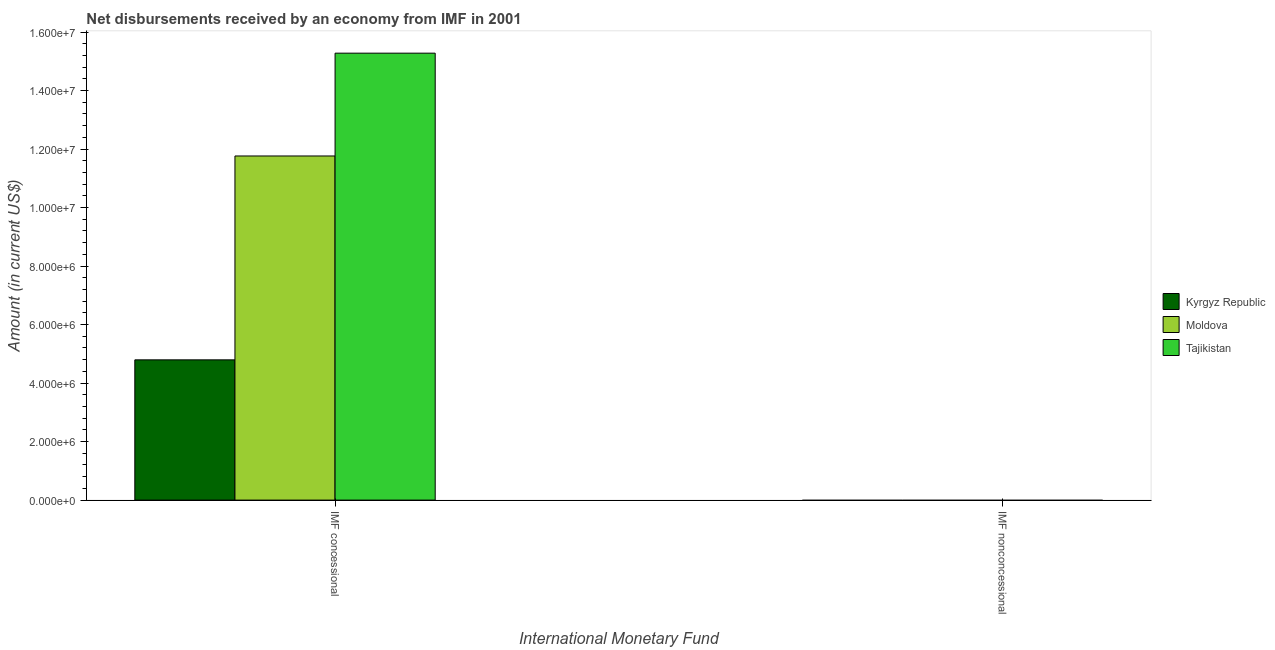Are the number of bars per tick equal to the number of legend labels?
Ensure brevity in your answer.  No. Are the number of bars on each tick of the X-axis equal?
Keep it short and to the point. No. How many bars are there on the 1st tick from the right?
Make the answer very short. 0. What is the label of the 2nd group of bars from the left?
Provide a succinct answer. IMF nonconcessional. Across all countries, what is the maximum net concessional disbursements from imf?
Your answer should be compact. 1.53e+07. Across all countries, what is the minimum net non concessional disbursements from imf?
Your answer should be very brief. 0. In which country was the net concessional disbursements from imf maximum?
Give a very brief answer. Tajikistan. What is the total net concessional disbursements from imf in the graph?
Your response must be concise. 3.18e+07. What is the difference between the net concessional disbursements from imf in Kyrgyz Republic and that in Moldova?
Ensure brevity in your answer.  -6.97e+06. What is the difference between the net non concessional disbursements from imf in Kyrgyz Republic and the net concessional disbursements from imf in Tajikistan?
Ensure brevity in your answer.  -1.53e+07. What is the average net concessional disbursements from imf per country?
Your answer should be very brief. 1.06e+07. What is the ratio of the net concessional disbursements from imf in Kyrgyz Republic to that in Moldova?
Ensure brevity in your answer.  0.41. Is the net concessional disbursements from imf in Moldova less than that in Kyrgyz Republic?
Your answer should be compact. No. In how many countries, is the net concessional disbursements from imf greater than the average net concessional disbursements from imf taken over all countries?
Offer a very short reply. 2. How many countries are there in the graph?
Your answer should be very brief. 3. What is the difference between two consecutive major ticks on the Y-axis?
Give a very brief answer. 2.00e+06. How are the legend labels stacked?
Your response must be concise. Vertical. What is the title of the graph?
Offer a terse response. Net disbursements received by an economy from IMF in 2001. Does "St. Lucia" appear as one of the legend labels in the graph?
Your answer should be very brief. No. What is the label or title of the X-axis?
Offer a terse response. International Monetary Fund. What is the label or title of the Y-axis?
Give a very brief answer. Amount (in current US$). What is the Amount (in current US$) in Kyrgyz Republic in IMF concessional?
Offer a terse response. 4.79e+06. What is the Amount (in current US$) of Moldova in IMF concessional?
Give a very brief answer. 1.18e+07. What is the Amount (in current US$) of Tajikistan in IMF concessional?
Keep it short and to the point. 1.53e+07. What is the Amount (in current US$) in Kyrgyz Republic in IMF nonconcessional?
Make the answer very short. 0. What is the Amount (in current US$) of Tajikistan in IMF nonconcessional?
Offer a very short reply. 0. Across all International Monetary Fund, what is the maximum Amount (in current US$) in Kyrgyz Republic?
Ensure brevity in your answer.  4.79e+06. Across all International Monetary Fund, what is the maximum Amount (in current US$) in Moldova?
Provide a succinct answer. 1.18e+07. Across all International Monetary Fund, what is the maximum Amount (in current US$) of Tajikistan?
Keep it short and to the point. 1.53e+07. What is the total Amount (in current US$) in Kyrgyz Republic in the graph?
Make the answer very short. 4.79e+06. What is the total Amount (in current US$) in Moldova in the graph?
Your response must be concise. 1.18e+07. What is the total Amount (in current US$) of Tajikistan in the graph?
Give a very brief answer. 1.53e+07. What is the average Amount (in current US$) in Kyrgyz Republic per International Monetary Fund?
Your answer should be compact. 2.40e+06. What is the average Amount (in current US$) in Moldova per International Monetary Fund?
Your answer should be compact. 5.88e+06. What is the average Amount (in current US$) in Tajikistan per International Monetary Fund?
Give a very brief answer. 7.64e+06. What is the difference between the Amount (in current US$) of Kyrgyz Republic and Amount (in current US$) of Moldova in IMF concessional?
Keep it short and to the point. -6.97e+06. What is the difference between the Amount (in current US$) in Kyrgyz Republic and Amount (in current US$) in Tajikistan in IMF concessional?
Your answer should be very brief. -1.05e+07. What is the difference between the Amount (in current US$) in Moldova and Amount (in current US$) in Tajikistan in IMF concessional?
Keep it short and to the point. -3.51e+06. What is the difference between the highest and the lowest Amount (in current US$) in Kyrgyz Republic?
Offer a terse response. 4.79e+06. What is the difference between the highest and the lowest Amount (in current US$) in Moldova?
Make the answer very short. 1.18e+07. What is the difference between the highest and the lowest Amount (in current US$) of Tajikistan?
Your answer should be compact. 1.53e+07. 